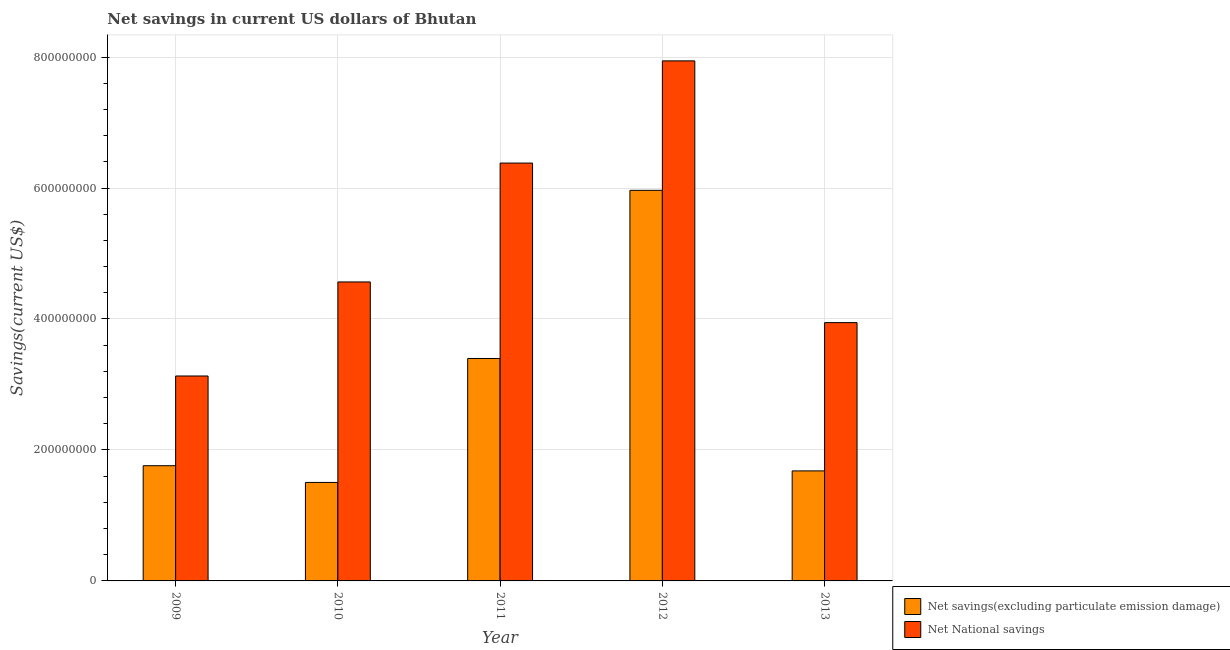Are the number of bars per tick equal to the number of legend labels?
Give a very brief answer. Yes. Are the number of bars on each tick of the X-axis equal?
Your answer should be compact. Yes. How many bars are there on the 1st tick from the left?
Your answer should be very brief. 2. What is the net savings(excluding particulate emission damage) in 2012?
Ensure brevity in your answer.  5.96e+08. Across all years, what is the maximum net savings(excluding particulate emission damage)?
Keep it short and to the point. 5.96e+08. Across all years, what is the minimum net savings(excluding particulate emission damage)?
Ensure brevity in your answer.  1.50e+08. In which year was the net savings(excluding particulate emission damage) maximum?
Make the answer very short. 2012. In which year was the net savings(excluding particulate emission damage) minimum?
Keep it short and to the point. 2010. What is the total net national savings in the graph?
Offer a very short reply. 2.60e+09. What is the difference between the net national savings in 2011 and that in 2013?
Offer a very short reply. 2.44e+08. What is the difference between the net savings(excluding particulate emission damage) in 2012 and the net national savings in 2013?
Your answer should be compact. 4.28e+08. What is the average net savings(excluding particulate emission damage) per year?
Provide a succinct answer. 2.86e+08. In the year 2010, what is the difference between the net national savings and net savings(excluding particulate emission damage)?
Provide a succinct answer. 0. What is the ratio of the net national savings in 2011 to that in 2013?
Your answer should be compact. 1.62. Is the net national savings in 2010 less than that in 2011?
Your response must be concise. Yes. What is the difference between the highest and the second highest net national savings?
Make the answer very short. 1.56e+08. What is the difference between the highest and the lowest net national savings?
Offer a very short reply. 4.81e+08. What does the 2nd bar from the left in 2011 represents?
Your response must be concise. Net National savings. What does the 1st bar from the right in 2012 represents?
Offer a terse response. Net National savings. How many bars are there?
Your answer should be compact. 10. Are all the bars in the graph horizontal?
Give a very brief answer. No. How many years are there in the graph?
Give a very brief answer. 5. What is the difference between two consecutive major ticks on the Y-axis?
Your response must be concise. 2.00e+08. Are the values on the major ticks of Y-axis written in scientific E-notation?
Ensure brevity in your answer.  No. Does the graph contain any zero values?
Your response must be concise. No. How are the legend labels stacked?
Keep it short and to the point. Vertical. What is the title of the graph?
Ensure brevity in your answer.  Net savings in current US dollars of Bhutan. What is the label or title of the X-axis?
Ensure brevity in your answer.  Year. What is the label or title of the Y-axis?
Offer a very short reply. Savings(current US$). What is the Savings(current US$) of Net savings(excluding particulate emission damage) in 2009?
Your response must be concise. 1.76e+08. What is the Savings(current US$) in Net National savings in 2009?
Offer a very short reply. 3.13e+08. What is the Savings(current US$) of Net savings(excluding particulate emission damage) in 2010?
Provide a succinct answer. 1.50e+08. What is the Savings(current US$) of Net National savings in 2010?
Provide a succinct answer. 4.57e+08. What is the Savings(current US$) of Net savings(excluding particulate emission damage) in 2011?
Offer a very short reply. 3.40e+08. What is the Savings(current US$) in Net National savings in 2011?
Your response must be concise. 6.38e+08. What is the Savings(current US$) of Net savings(excluding particulate emission damage) in 2012?
Make the answer very short. 5.96e+08. What is the Savings(current US$) in Net National savings in 2012?
Your answer should be very brief. 7.94e+08. What is the Savings(current US$) of Net savings(excluding particulate emission damage) in 2013?
Keep it short and to the point. 1.68e+08. What is the Savings(current US$) of Net National savings in 2013?
Give a very brief answer. 3.94e+08. Across all years, what is the maximum Savings(current US$) of Net savings(excluding particulate emission damage)?
Offer a very short reply. 5.96e+08. Across all years, what is the maximum Savings(current US$) in Net National savings?
Give a very brief answer. 7.94e+08. Across all years, what is the minimum Savings(current US$) of Net savings(excluding particulate emission damage)?
Your answer should be compact. 1.50e+08. Across all years, what is the minimum Savings(current US$) in Net National savings?
Keep it short and to the point. 3.13e+08. What is the total Savings(current US$) of Net savings(excluding particulate emission damage) in the graph?
Ensure brevity in your answer.  1.43e+09. What is the total Savings(current US$) in Net National savings in the graph?
Your answer should be compact. 2.60e+09. What is the difference between the Savings(current US$) of Net savings(excluding particulate emission damage) in 2009 and that in 2010?
Ensure brevity in your answer.  2.55e+07. What is the difference between the Savings(current US$) in Net National savings in 2009 and that in 2010?
Keep it short and to the point. -1.44e+08. What is the difference between the Savings(current US$) of Net savings(excluding particulate emission damage) in 2009 and that in 2011?
Your response must be concise. -1.64e+08. What is the difference between the Savings(current US$) in Net National savings in 2009 and that in 2011?
Your answer should be compact. -3.25e+08. What is the difference between the Savings(current US$) of Net savings(excluding particulate emission damage) in 2009 and that in 2012?
Ensure brevity in your answer.  -4.21e+08. What is the difference between the Savings(current US$) of Net National savings in 2009 and that in 2012?
Ensure brevity in your answer.  -4.81e+08. What is the difference between the Savings(current US$) in Net savings(excluding particulate emission damage) in 2009 and that in 2013?
Provide a succinct answer. 7.91e+06. What is the difference between the Savings(current US$) of Net National savings in 2009 and that in 2013?
Your answer should be very brief. -8.15e+07. What is the difference between the Savings(current US$) in Net savings(excluding particulate emission damage) in 2010 and that in 2011?
Give a very brief answer. -1.89e+08. What is the difference between the Savings(current US$) in Net National savings in 2010 and that in 2011?
Ensure brevity in your answer.  -1.82e+08. What is the difference between the Savings(current US$) of Net savings(excluding particulate emission damage) in 2010 and that in 2012?
Your answer should be compact. -4.46e+08. What is the difference between the Savings(current US$) in Net National savings in 2010 and that in 2012?
Your answer should be compact. -3.38e+08. What is the difference between the Savings(current US$) in Net savings(excluding particulate emission damage) in 2010 and that in 2013?
Provide a short and direct response. -1.76e+07. What is the difference between the Savings(current US$) in Net National savings in 2010 and that in 2013?
Your response must be concise. 6.21e+07. What is the difference between the Savings(current US$) of Net savings(excluding particulate emission damage) in 2011 and that in 2012?
Offer a very short reply. -2.57e+08. What is the difference between the Savings(current US$) in Net National savings in 2011 and that in 2012?
Your response must be concise. -1.56e+08. What is the difference between the Savings(current US$) of Net savings(excluding particulate emission damage) in 2011 and that in 2013?
Keep it short and to the point. 1.72e+08. What is the difference between the Savings(current US$) in Net National savings in 2011 and that in 2013?
Your response must be concise. 2.44e+08. What is the difference between the Savings(current US$) of Net savings(excluding particulate emission damage) in 2012 and that in 2013?
Provide a short and direct response. 4.28e+08. What is the difference between the Savings(current US$) in Net National savings in 2012 and that in 2013?
Give a very brief answer. 4.00e+08. What is the difference between the Savings(current US$) in Net savings(excluding particulate emission damage) in 2009 and the Savings(current US$) in Net National savings in 2010?
Offer a very short reply. -2.81e+08. What is the difference between the Savings(current US$) in Net savings(excluding particulate emission damage) in 2009 and the Savings(current US$) in Net National savings in 2011?
Give a very brief answer. -4.62e+08. What is the difference between the Savings(current US$) of Net savings(excluding particulate emission damage) in 2009 and the Savings(current US$) of Net National savings in 2012?
Provide a succinct answer. -6.18e+08. What is the difference between the Savings(current US$) of Net savings(excluding particulate emission damage) in 2009 and the Savings(current US$) of Net National savings in 2013?
Your answer should be compact. -2.19e+08. What is the difference between the Savings(current US$) in Net savings(excluding particulate emission damage) in 2010 and the Savings(current US$) in Net National savings in 2011?
Offer a terse response. -4.88e+08. What is the difference between the Savings(current US$) of Net savings(excluding particulate emission damage) in 2010 and the Savings(current US$) of Net National savings in 2012?
Offer a terse response. -6.44e+08. What is the difference between the Savings(current US$) in Net savings(excluding particulate emission damage) in 2010 and the Savings(current US$) in Net National savings in 2013?
Make the answer very short. -2.44e+08. What is the difference between the Savings(current US$) of Net savings(excluding particulate emission damage) in 2011 and the Savings(current US$) of Net National savings in 2012?
Provide a succinct answer. -4.54e+08. What is the difference between the Savings(current US$) of Net savings(excluding particulate emission damage) in 2011 and the Savings(current US$) of Net National savings in 2013?
Provide a succinct answer. -5.48e+07. What is the difference between the Savings(current US$) in Net savings(excluding particulate emission damage) in 2012 and the Savings(current US$) in Net National savings in 2013?
Provide a succinct answer. 2.02e+08. What is the average Savings(current US$) in Net savings(excluding particulate emission damage) per year?
Provide a succinct answer. 2.86e+08. What is the average Savings(current US$) of Net National savings per year?
Keep it short and to the point. 5.19e+08. In the year 2009, what is the difference between the Savings(current US$) of Net savings(excluding particulate emission damage) and Savings(current US$) of Net National savings?
Ensure brevity in your answer.  -1.37e+08. In the year 2010, what is the difference between the Savings(current US$) in Net savings(excluding particulate emission damage) and Savings(current US$) in Net National savings?
Your answer should be compact. -3.06e+08. In the year 2011, what is the difference between the Savings(current US$) in Net savings(excluding particulate emission damage) and Savings(current US$) in Net National savings?
Your response must be concise. -2.98e+08. In the year 2012, what is the difference between the Savings(current US$) of Net savings(excluding particulate emission damage) and Savings(current US$) of Net National savings?
Provide a short and direct response. -1.98e+08. In the year 2013, what is the difference between the Savings(current US$) of Net savings(excluding particulate emission damage) and Savings(current US$) of Net National savings?
Your answer should be compact. -2.26e+08. What is the ratio of the Savings(current US$) in Net savings(excluding particulate emission damage) in 2009 to that in 2010?
Your response must be concise. 1.17. What is the ratio of the Savings(current US$) of Net National savings in 2009 to that in 2010?
Provide a short and direct response. 0.69. What is the ratio of the Savings(current US$) of Net savings(excluding particulate emission damage) in 2009 to that in 2011?
Keep it short and to the point. 0.52. What is the ratio of the Savings(current US$) of Net National savings in 2009 to that in 2011?
Provide a succinct answer. 0.49. What is the ratio of the Savings(current US$) in Net savings(excluding particulate emission damage) in 2009 to that in 2012?
Make the answer very short. 0.29. What is the ratio of the Savings(current US$) in Net National savings in 2009 to that in 2012?
Offer a terse response. 0.39. What is the ratio of the Savings(current US$) of Net savings(excluding particulate emission damage) in 2009 to that in 2013?
Keep it short and to the point. 1.05. What is the ratio of the Savings(current US$) in Net National savings in 2009 to that in 2013?
Keep it short and to the point. 0.79. What is the ratio of the Savings(current US$) in Net savings(excluding particulate emission damage) in 2010 to that in 2011?
Provide a short and direct response. 0.44. What is the ratio of the Savings(current US$) of Net National savings in 2010 to that in 2011?
Offer a terse response. 0.72. What is the ratio of the Savings(current US$) in Net savings(excluding particulate emission damage) in 2010 to that in 2012?
Your answer should be compact. 0.25. What is the ratio of the Savings(current US$) in Net National savings in 2010 to that in 2012?
Your answer should be very brief. 0.57. What is the ratio of the Savings(current US$) of Net savings(excluding particulate emission damage) in 2010 to that in 2013?
Your answer should be compact. 0.9. What is the ratio of the Savings(current US$) of Net National savings in 2010 to that in 2013?
Keep it short and to the point. 1.16. What is the ratio of the Savings(current US$) of Net savings(excluding particulate emission damage) in 2011 to that in 2012?
Provide a short and direct response. 0.57. What is the ratio of the Savings(current US$) in Net National savings in 2011 to that in 2012?
Offer a very short reply. 0.8. What is the ratio of the Savings(current US$) in Net savings(excluding particulate emission damage) in 2011 to that in 2013?
Offer a terse response. 2.02. What is the ratio of the Savings(current US$) in Net National savings in 2011 to that in 2013?
Make the answer very short. 1.62. What is the ratio of the Savings(current US$) in Net savings(excluding particulate emission damage) in 2012 to that in 2013?
Make the answer very short. 3.55. What is the ratio of the Savings(current US$) of Net National savings in 2012 to that in 2013?
Your answer should be very brief. 2.01. What is the difference between the highest and the second highest Savings(current US$) of Net savings(excluding particulate emission damage)?
Keep it short and to the point. 2.57e+08. What is the difference between the highest and the second highest Savings(current US$) in Net National savings?
Make the answer very short. 1.56e+08. What is the difference between the highest and the lowest Savings(current US$) of Net savings(excluding particulate emission damage)?
Provide a succinct answer. 4.46e+08. What is the difference between the highest and the lowest Savings(current US$) in Net National savings?
Give a very brief answer. 4.81e+08. 